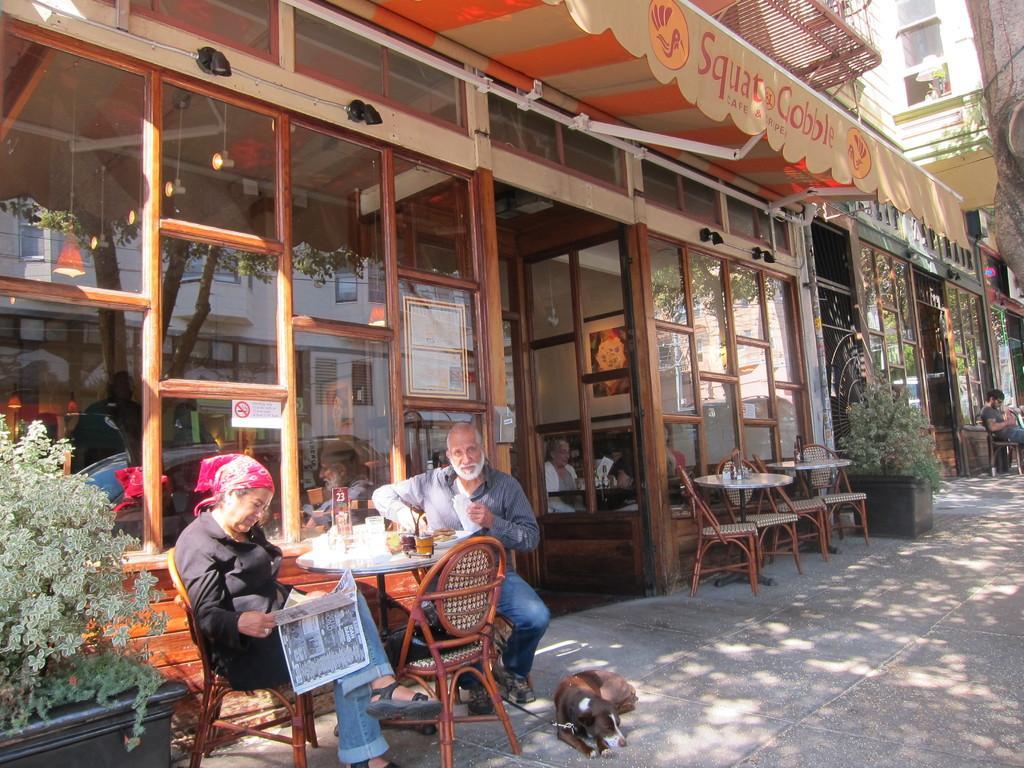Could you give a brief overview of what you see in this image? There are two persons sitting on chair. The woman is reading news paper. This is a dog and plant. 